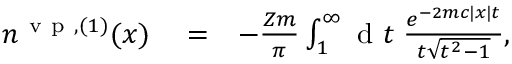<formula> <loc_0><loc_0><loc_500><loc_500>\begin{array} { r l r } { n ^ { v p , ( 1 ) } ( x ) } & = } & { - \frac { Z m } { \pi } \int _ { 1 } ^ { \infty } { d } t \, \frac { e ^ { - 2 m c | x | t } } { t \sqrt { t ^ { 2 } - 1 } } , } \end{array}</formula> 